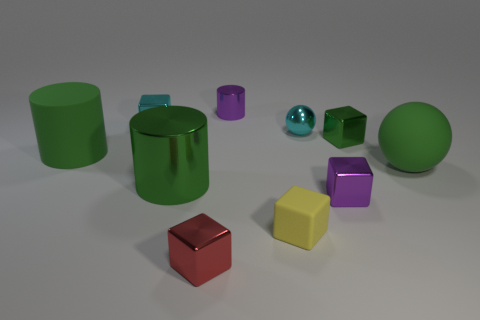The tiny purple metallic object in front of the tiny purple metallic thing on the left side of the purple thing in front of the metallic ball is what shape?
Give a very brief answer. Cube. What is the shape of the tiny shiny thing that is the same color as the large shiny cylinder?
Provide a succinct answer. Cube. How many objects are big blue metal spheres or large matte objects that are to the left of the small ball?
Provide a short and direct response. 1. Does the green rubber object that is to the right of the yellow matte block have the same size as the large green metallic object?
Offer a very short reply. Yes. What is the material of the big green object to the right of the small green metallic thing?
Make the answer very short. Rubber. Are there an equal number of big rubber balls to the left of the green rubber sphere and tiny balls on the right side of the small yellow rubber cube?
Offer a very short reply. No. What is the color of the other tiny matte thing that is the same shape as the small red thing?
Keep it short and to the point. Yellow. Is there anything else that is the same color as the rubber cube?
Provide a short and direct response. No. How many metallic things are either small purple blocks or red objects?
Ensure brevity in your answer.  2. Is the color of the big rubber cylinder the same as the large rubber sphere?
Offer a terse response. Yes. 